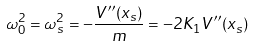<formula> <loc_0><loc_0><loc_500><loc_500>\omega _ { 0 } ^ { 2 } = \omega _ { s } ^ { 2 } = - \frac { V ^ { \prime \prime } ( x _ { s } ) } { m } = - 2 K _ { 1 } V ^ { \prime \prime } ( x _ { s } )</formula> 